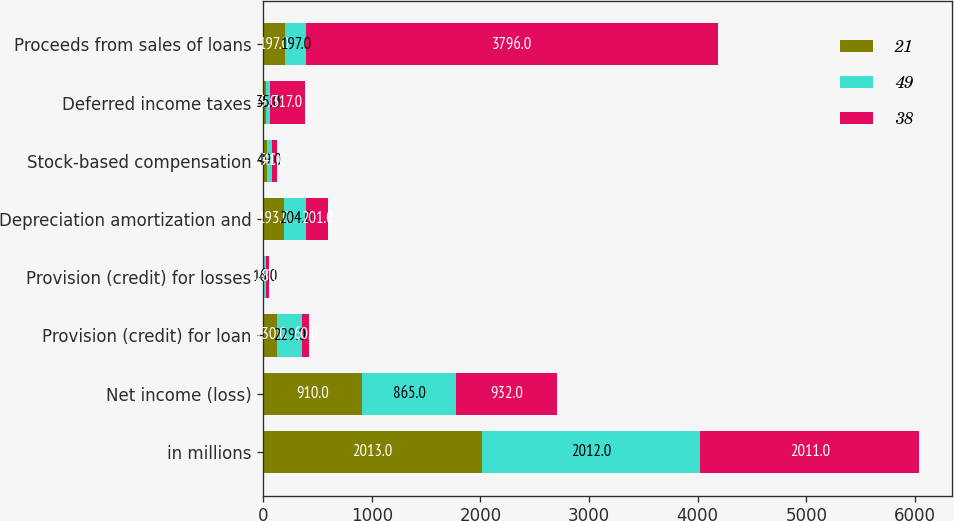<chart> <loc_0><loc_0><loc_500><loc_500><stacked_bar_chart><ecel><fcel>in millions<fcel>Net income (loss)<fcel>Provision (credit) for loan<fcel>Provision (credit) for losses<fcel>Depreciation amortization and<fcel>Stock-based compensation<fcel>Deferred income taxes<fcel>Proceeds from sales of loans<nl><fcel>21<fcel>2013<fcel>910<fcel>130<fcel>8<fcel>193<fcel>35<fcel>29<fcel>197<nl><fcel>49<fcel>2012<fcel>865<fcel>229<fcel>16<fcel>204<fcel>49<fcel>35<fcel>197<nl><fcel>38<fcel>2011<fcel>932<fcel>60<fcel>28<fcel>201<fcel>41<fcel>317<fcel>3796<nl></chart> 